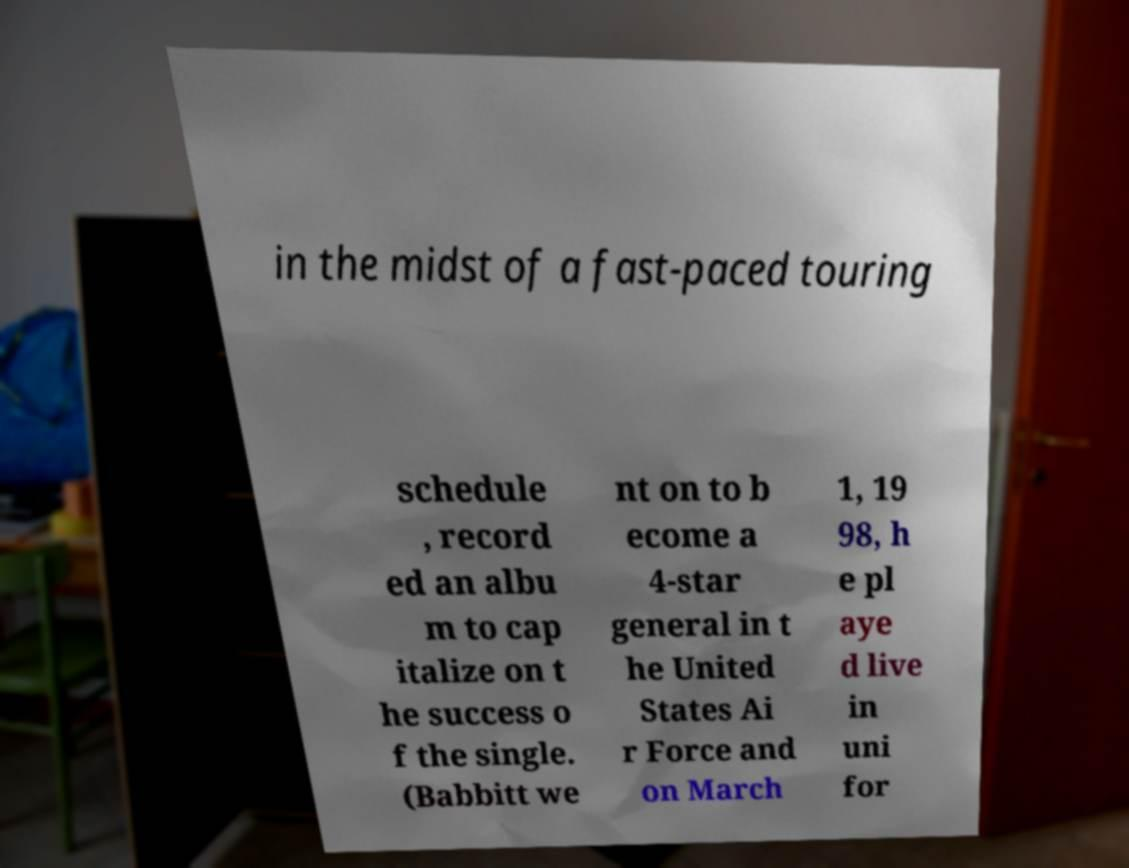Can you read and provide the text displayed in the image?This photo seems to have some interesting text. Can you extract and type it out for me? in the midst of a fast-paced touring schedule , record ed an albu m to cap italize on t he success o f the single. (Babbitt we nt on to b ecome a 4-star general in t he United States Ai r Force and on March 1, 19 98, h e pl aye d live in uni for 